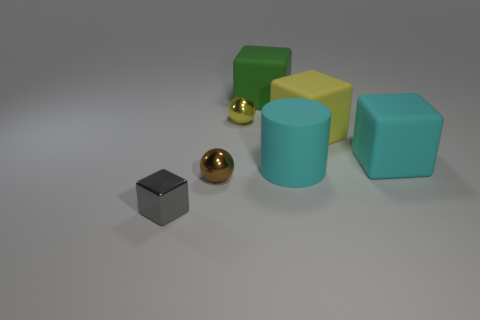Add 3 brown balls. How many objects exist? 10 Subtract all blocks. How many objects are left? 3 Add 5 small brown metal cylinders. How many small brown metal cylinders exist? 5 Subtract 0 purple cubes. How many objects are left? 7 Subtract all cyan matte blocks. Subtract all tiny rubber cylinders. How many objects are left? 6 Add 6 cyan things. How many cyan things are left? 8 